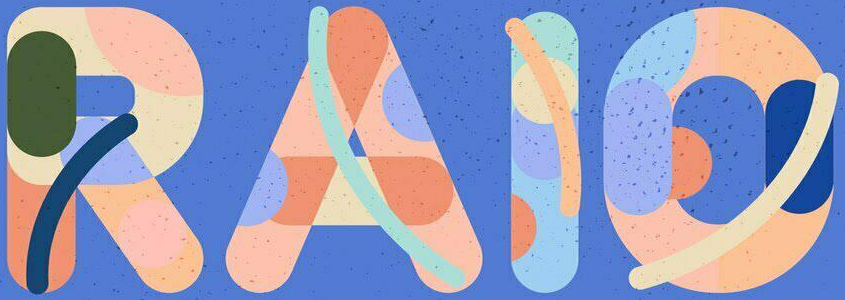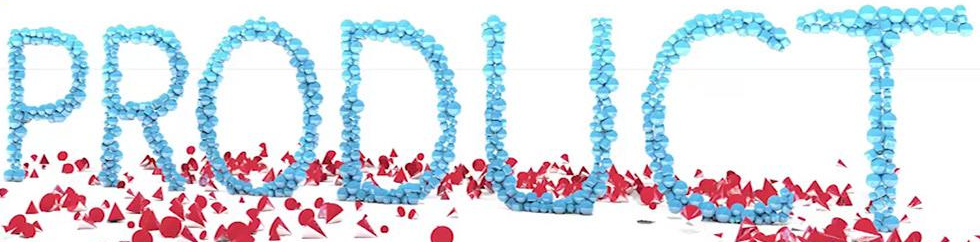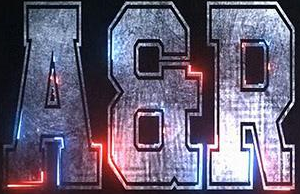What text is displayed in these images sequentially, separated by a semicolon? RAIO; PRODUCT; AER 